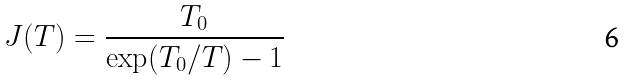<formula> <loc_0><loc_0><loc_500><loc_500>J ( T ) = \frac { T _ { 0 } } { \exp ( T _ { 0 } / T ) - 1 }</formula> 